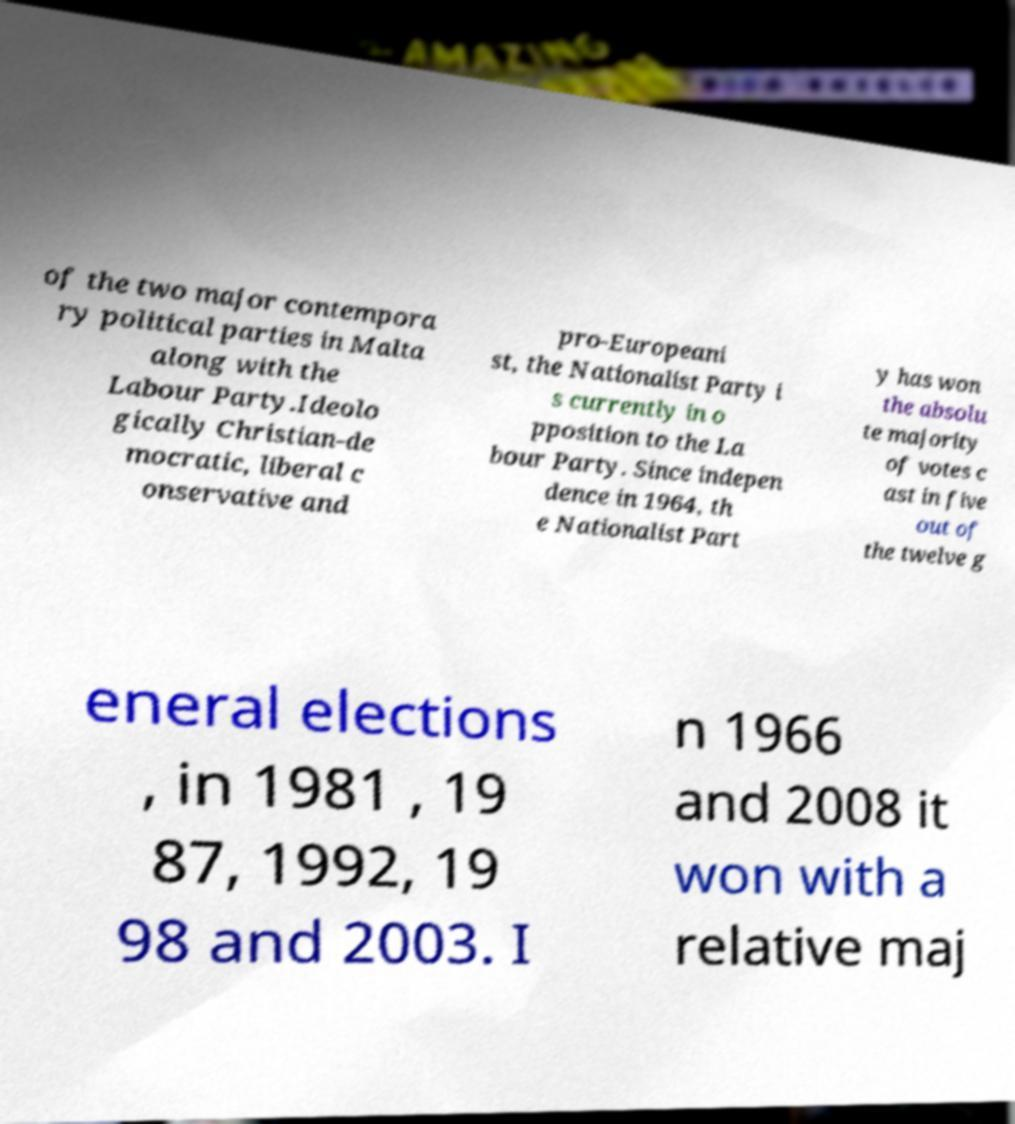Could you extract and type out the text from this image? of the two major contempora ry political parties in Malta along with the Labour Party.Ideolo gically Christian-de mocratic, liberal c onservative and pro-Europeani st, the Nationalist Party i s currently in o pposition to the La bour Party. Since indepen dence in 1964, th e Nationalist Part y has won the absolu te majority of votes c ast in five out of the twelve g eneral elections , in 1981 , 19 87, 1992, 19 98 and 2003. I n 1966 and 2008 it won with a relative maj 